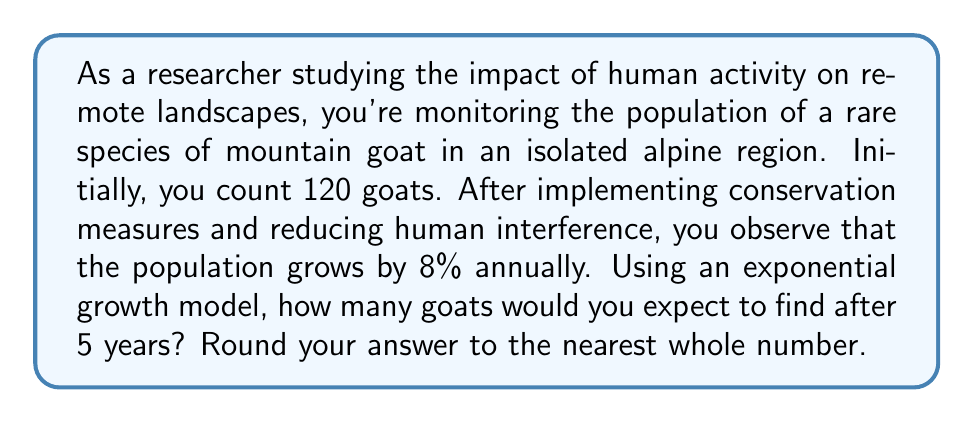Could you help me with this problem? To solve this problem, we'll use the exponential growth formula:

$$A = P(1 + r)^t$$

Where:
$A$ = Final amount
$P$ = Initial population
$r$ = Growth rate (as a decimal)
$t$ = Time in years

Given:
$P = 120$ (initial population)
$r = 0.08$ (8% annual growth rate)
$t = 5$ years

Let's plug these values into the formula:

$$A = 120(1 + 0.08)^5$$

Now, let's calculate step-by-step:

1) First, calculate $(1 + 0.08)$:
   $1 + 0.08 = 1.08$

2) Now, raise 1.08 to the power of 5:
   $1.08^5 \approx 1.469328$

3) Multiply this by the initial population:
   $120 \times 1.469328 \approx 176.31936$

4) Round to the nearest whole number:
   $176.31936 \approx 176$

Therefore, after 5 years, you would expect to find approximately 176 goats.
Answer: 176 goats 